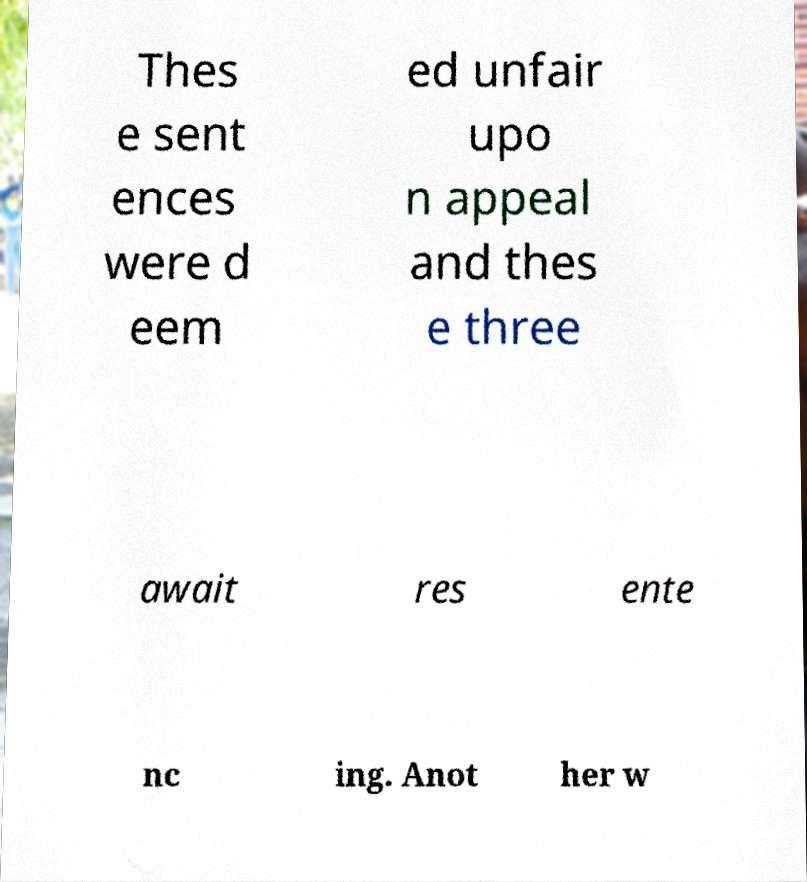Please read and relay the text visible in this image. What does it say? Thes e sent ences were d eem ed unfair upo n appeal and thes e three await res ente nc ing. Anot her w 